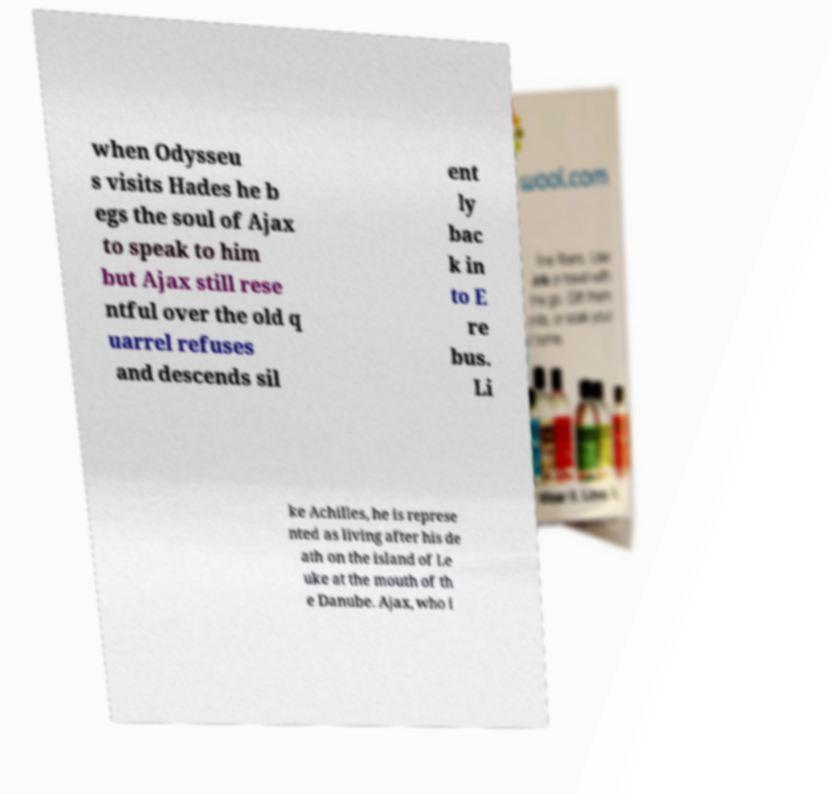Could you extract and type out the text from this image? when Odysseu s visits Hades he b egs the soul of Ajax to speak to him but Ajax still rese ntful over the old q uarrel refuses and descends sil ent ly bac k in to E re bus. Li ke Achilles, he is represe nted as living after his de ath on the island of Le uke at the mouth of th e Danube. Ajax, who i 